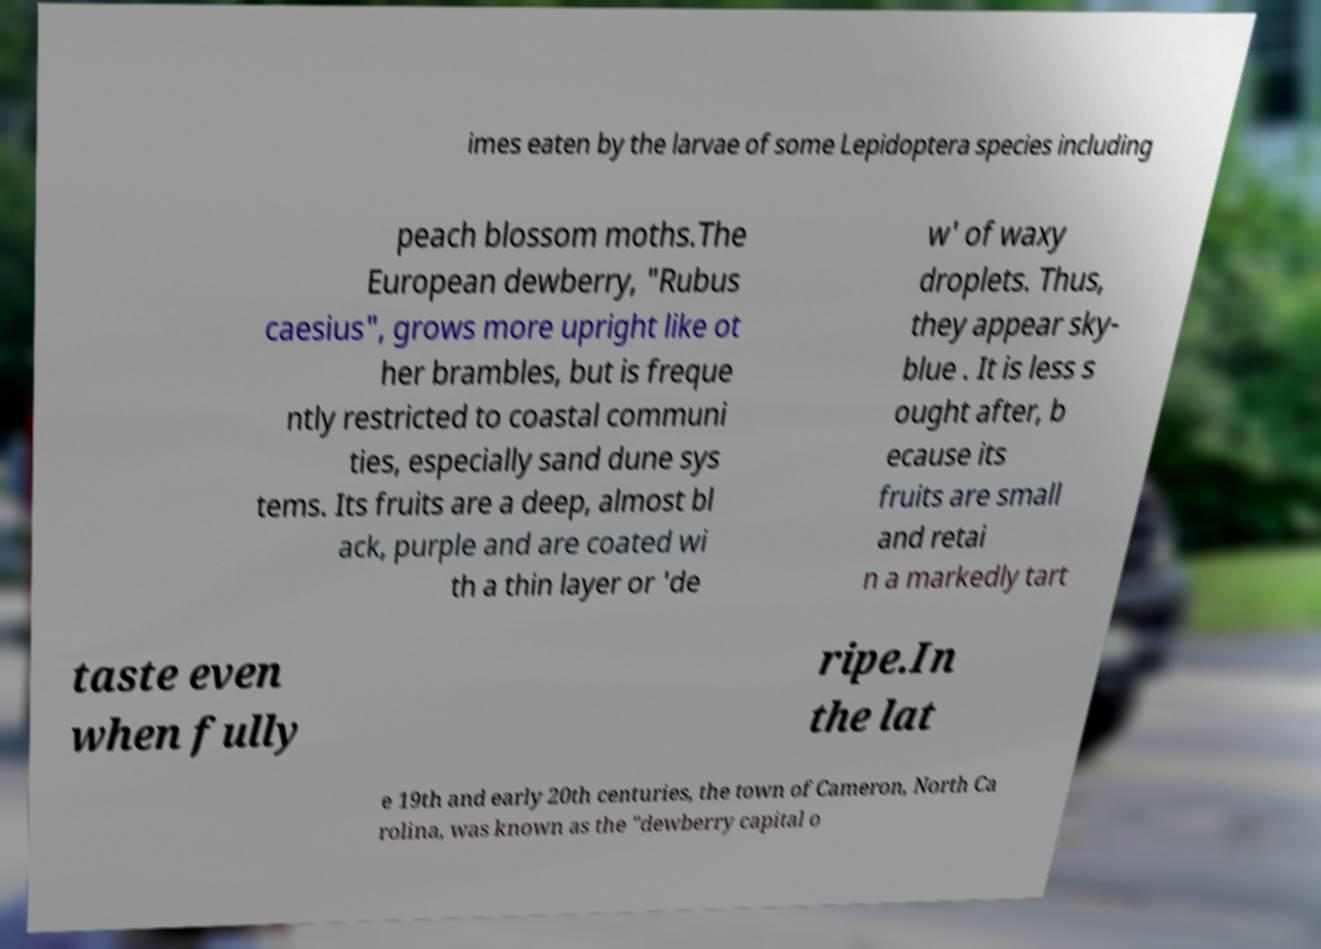Could you extract and type out the text from this image? imes eaten by the larvae of some Lepidoptera species including peach blossom moths.The European dewberry, "Rubus caesius", grows more upright like ot her brambles, but is freque ntly restricted to coastal communi ties, especially sand dune sys tems. Its fruits are a deep, almost bl ack, purple and are coated wi th a thin layer or 'de w' of waxy droplets. Thus, they appear sky- blue . It is less s ought after, b ecause its fruits are small and retai n a markedly tart taste even when fully ripe.In the lat e 19th and early 20th centuries, the town of Cameron, North Ca rolina, was known as the "dewberry capital o 